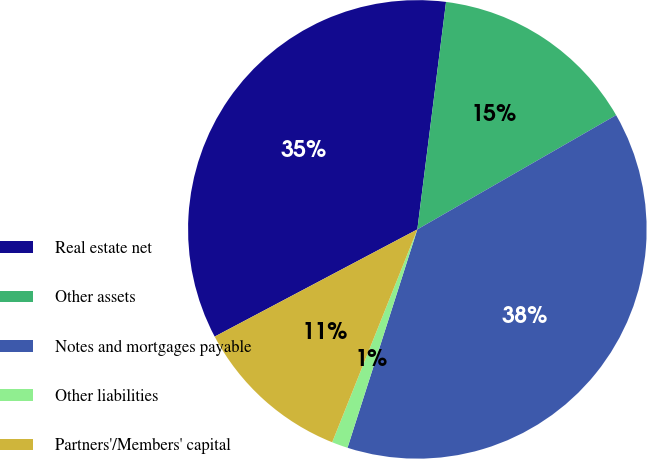<chart> <loc_0><loc_0><loc_500><loc_500><pie_chart><fcel>Real estate net<fcel>Other assets<fcel>Notes and mortgages payable<fcel>Other liabilities<fcel>Partners'/Members' capital<nl><fcel>34.74%<fcel>14.7%<fcel>38.23%<fcel>1.13%<fcel>11.2%<nl></chart> 